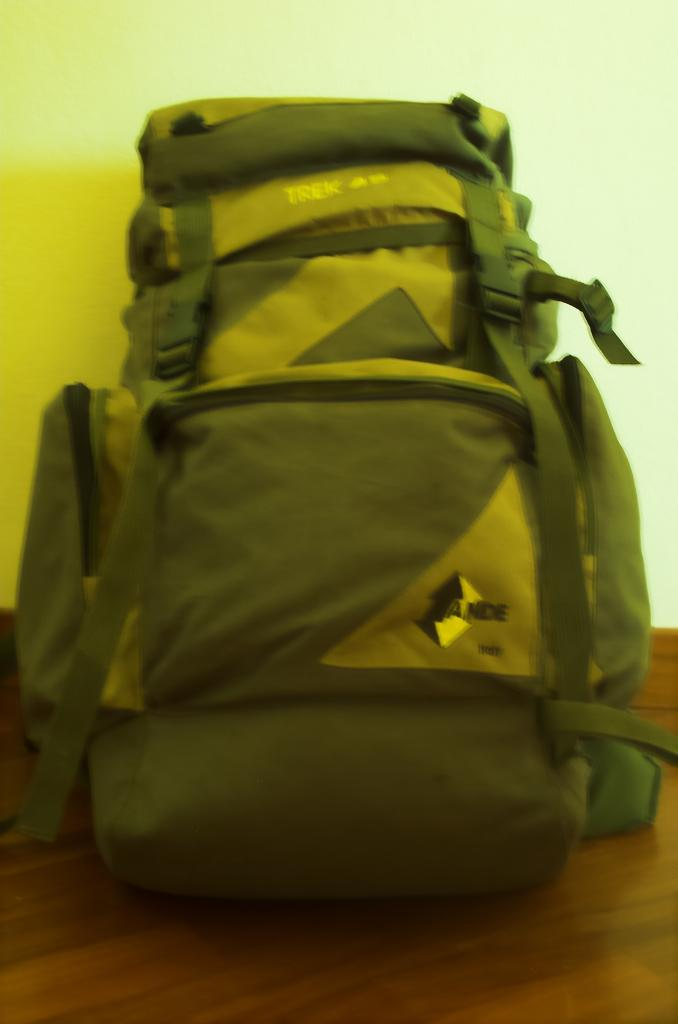What object is visible on the table in the image? There is a backpack on the table in the image. How many salt shakers are on the table next to the backpack in the image? There is no salt shaker mentioned or visible in the image; only a backpack on a table is present. 